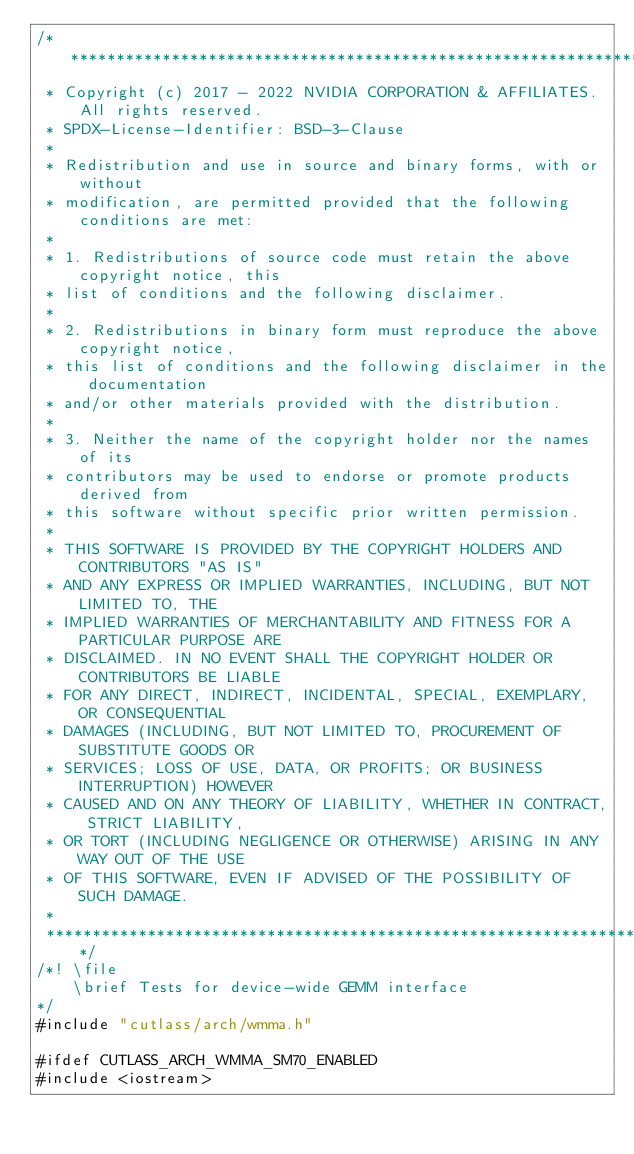Convert code to text. <code><loc_0><loc_0><loc_500><loc_500><_Cuda_>/***************************************************************************************************
 * Copyright (c) 2017 - 2022 NVIDIA CORPORATION & AFFILIATES. All rights reserved.
 * SPDX-License-Identifier: BSD-3-Clause
 *
 * Redistribution and use in source and binary forms, with or without
 * modification, are permitted provided that the following conditions are met:
 *
 * 1. Redistributions of source code must retain the above copyright notice, this
 * list of conditions and the following disclaimer.
 *
 * 2. Redistributions in binary form must reproduce the above copyright notice,
 * this list of conditions and the following disclaimer in the documentation
 * and/or other materials provided with the distribution.
 *
 * 3. Neither the name of the copyright holder nor the names of its
 * contributors may be used to endorse or promote products derived from
 * this software without specific prior written permission.
 *
 * THIS SOFTWARE IS PROVIDED BY THE COPYRIGHT HOLDERS AND CONTRIBUTORS "AS IS"
 * AND ANY EXPRESS OR IMPLIED WARRANTIES, INCLUDING, BUT NOT LIMITED TO, THE
 * IMPLIED WARRANTIES OF MERCHANTABILITY AND FITNESS FOR A PARTICULAR PURPOSE ARE
 * DISCLAIMED. IN NO EVENT SHALL THE COPYRIGHT HOLDER OR CONTRIBUTORS BE LIABLE
 * FOR ANY DIRECT, INDIRECT, INCIDENTAL, SPECIAL, EXEMPLARY, OR CONSEQUENTIAL
 * DAMAGES (INCLUDING, BUT NOT LIMITED TO, PROCUREMENT OF SUBSTITUTE GOODS OR
 * SERVICES; LOSS OF USE, DATA, OR PROFITS; OR BUSINESS INTERRUPTION) HOWEVER
 * CAUSED AND ON ANY THEORY OF LIABILITY, WHETHER IN CONTRACT, STRICT LIABILITY,
 * OR TORT (INCLUDING NEGLIGENCE OR OTHERWISE) ARISING IN ANY WAY OUT OF THE USE
 * OF THIS SOFTWARE, EVEN IF ADVISED OF THE POSSIBILITY OF SUCH DAMAGE.
 *
 **************************************************************************************************/
/*! \file
    \brief Tests for device-wide GEMM interface
*/
#include "cutlass/arch/wmma.h"

#ifdef CUTLASS_ARCH_WMMA_SM70_ENABLED
#include <iostream>
</code> 